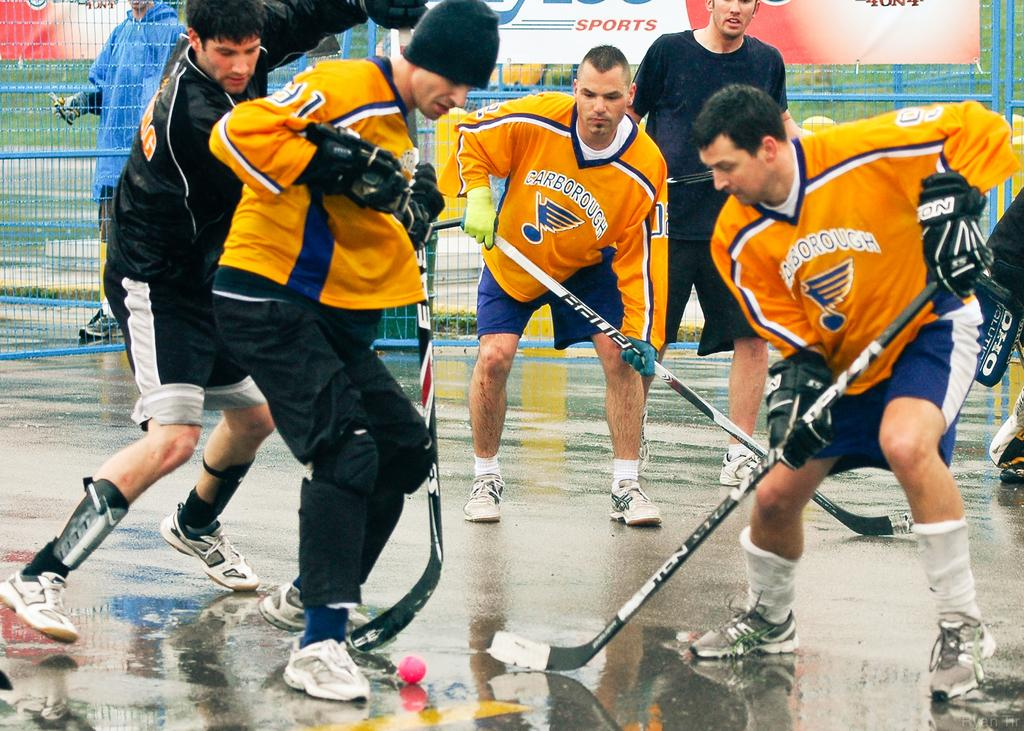<image>
Render a clear and concise summary of the photo. Hockey players with orange jerseys from the school carborough 